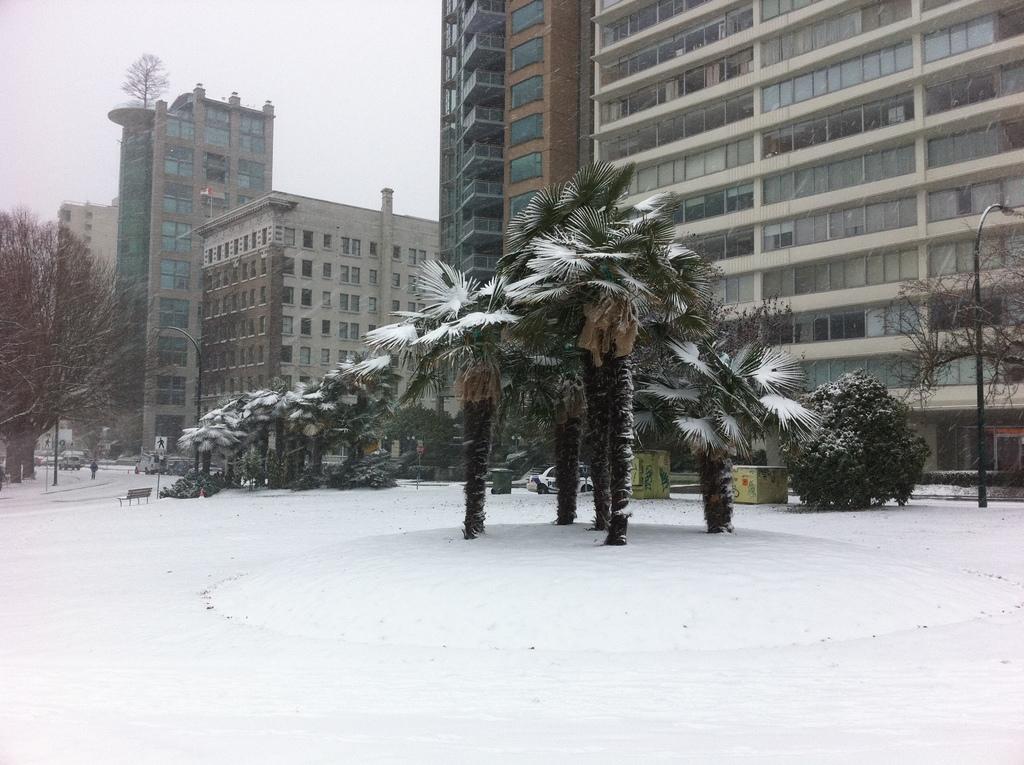Please provide a concise description of this image. In this picture we can see the white and brown buildings with many windows. In the front bottom side there are some coconut trees and snow on the ground. On the left corner we can see dry trees and buildings. 